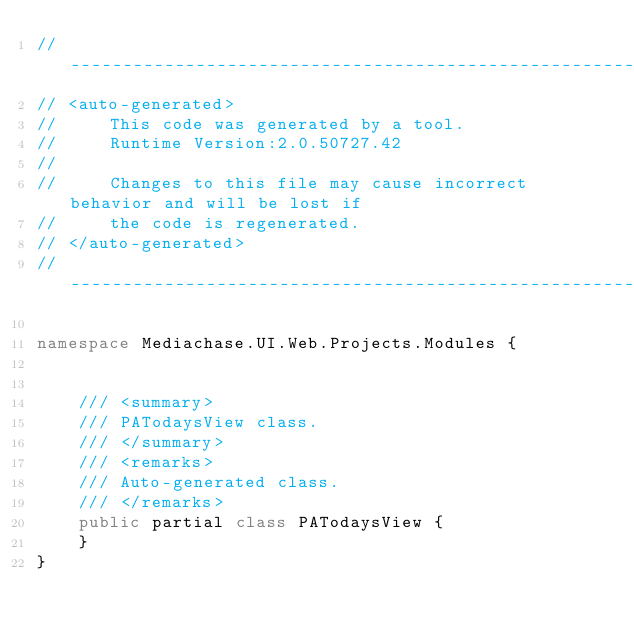Convert code to text. <code><loc_0><loc_0><loc_500><loc_500><_C#_>//------------------------------------------------------------------------------
// <auto-generated>
//     This code was generated by a tool.
//     Runtime Version:2.0.50727.42
//
//     Changes to this file may cause incorrect behavior and will be lost if
//     the code is regenerated.
// </auto-generated>
//------------------------------------------------------------------------------

namespace Mediachase.UI.Web.Projects.Modules {
    
    
    /// <summary>
    /// PATodaysView class.
    /// </summary>
    /// <remarks>
    /// Auto-generated class.
    /// </remarks>
    public partial class PATodaysView {
    }
}
</code> 